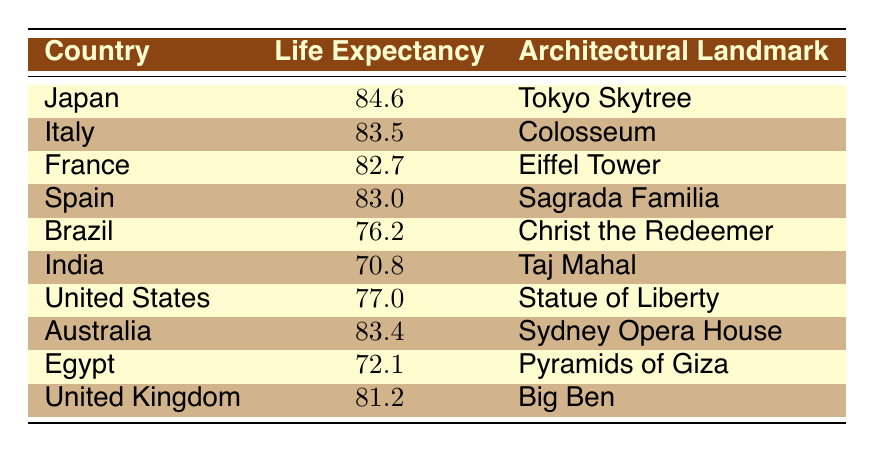What is the life expectancy of Japan? The life expectancy of Japan can be directly found in the table. It is listed under the "Life Expectancy" column next to Japan.
Answer: 84.6 Which country has the lowest life expectancy in this table? To find the country with the lowest life expectancy, I checked all the values in the "Life Expectancy" column. The lowest value is 70.8, which belongs to India.
Answer: India What is the average life expectancy of the countries listed in the table? First, I sum up all the life expectancies: 84.6 + 83.5 + 82.7 + 83.0 + 76.2 + 70.8 + 77.0 + 83.4 + 72.1 + 81.2. This total is 813.5. There are 10 countries, so I divide by 10: 813.5 / 10 = 81.35.
Answer: 81.4 Is France's life expectancy higher than that of the United Kingdom? Looking at the "Life Expectancy" values, France has 82.7 and the United Kingdom has 81.2. Since 82.7 is greater than 81.2, France's life expectancy is indeed higher.
Answer: Yes How much higher is the life expectancy of Australia compared to Brazil? Australia's life expectancy is 83.4 and Brazil's is 76.2. I subtract the two values: 83.4 - 76.2 = 7.2, indicating that Australia's life expectancy is 7.2 years higher than Brazil's.
Answer: 7.2 